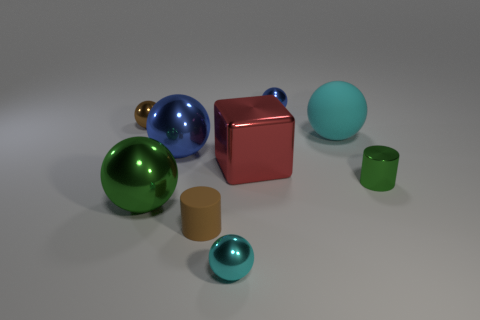Subtract all large blue metal balls. How many balls are left? 5 Subtract all brown balls. How many balls are left? 5 Subtract all gray balls. Subtract all yellow cylinders. How many balls are left? 6 Add 1 big cyan objects. How many objects exist? 10 Subtract all cylinders. How many objects are left? 7 Subtract 0 blue blocks. How many objects are left? 9 Subtract all small yellow metal balls. Subtract all brown cylinders. How many objects are left? 8 Add 5 brown rubber cylinders. How many brown rubber cylinders are left? 6 Add 9 large blue objects. How many large blue objects exist? 10 